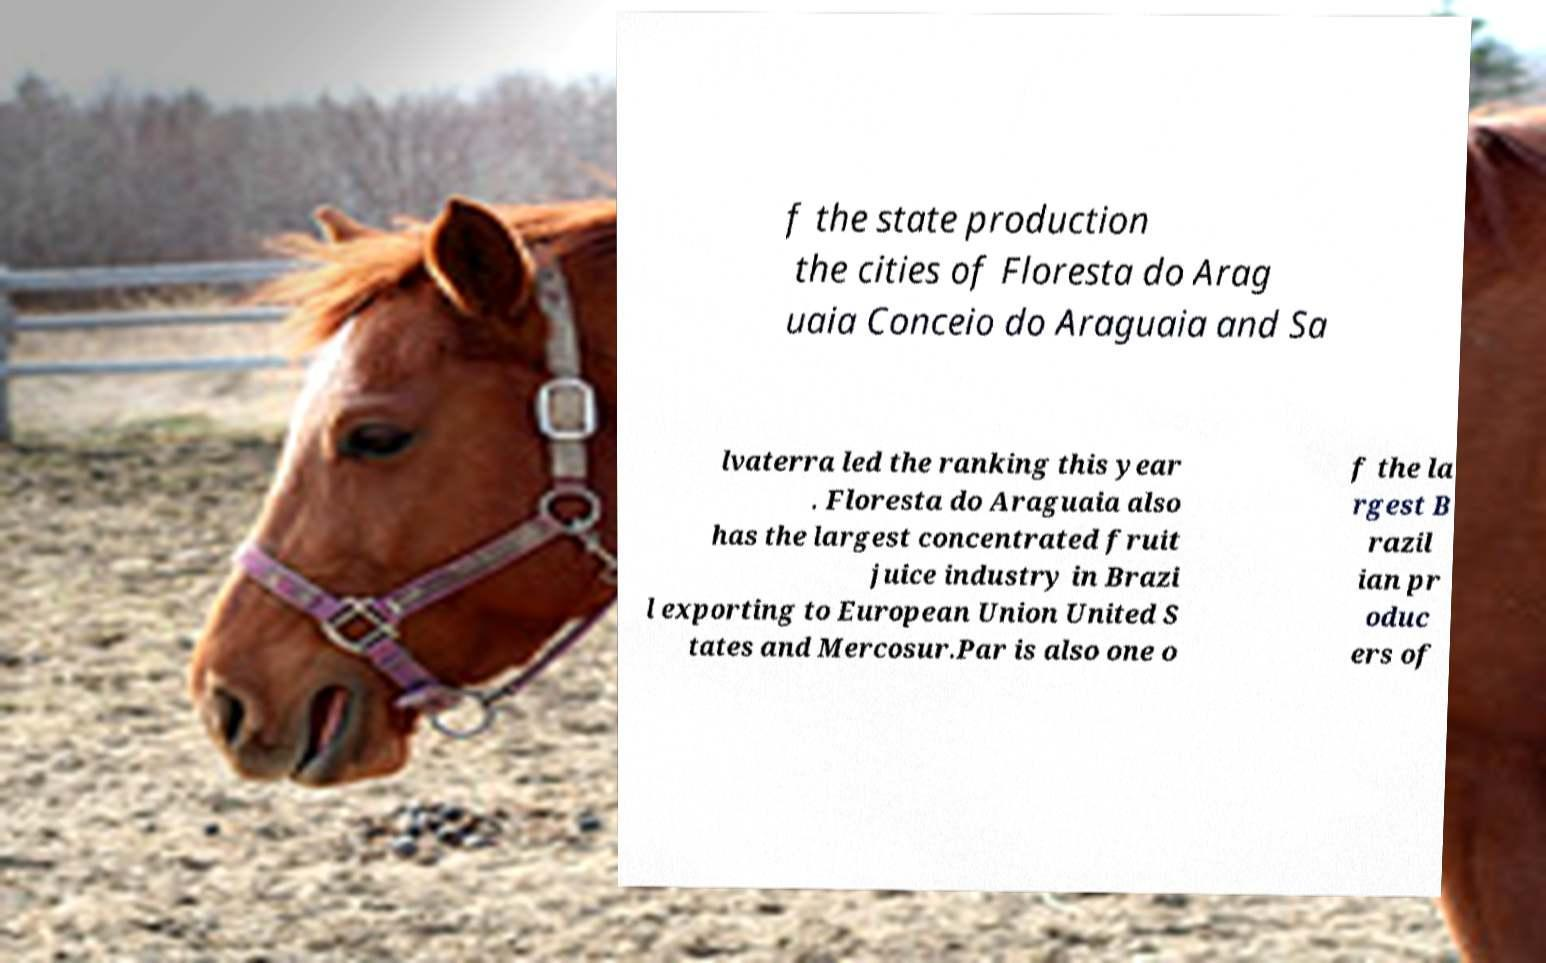I need the written content from this picture converted into text. Can you do that? f the state production the cities of Floresta do Arag uaia Conceio do Araguaia and Sa lvaterra led the ranking this year . Floresta do Araguaia also has the largest concentrated fruit juice industry in Brazi l exporting to European Union United S tates and Mercosur.Par is also one o f the la rgest B razil ian pr oduc ers of 